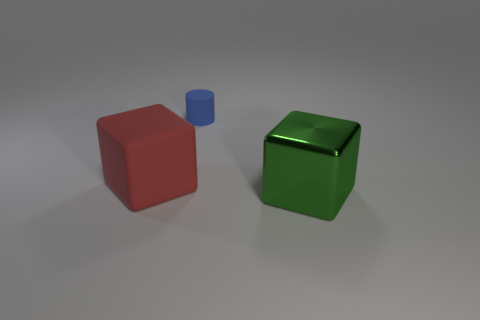Add 3 red rubber cubes. How many objects exist? 6 Subtract all cylinders. How many objects are left? 2 Add 3 brown rubber objects. How many brown rubber objects exist? 3 Subtract 0 cyan balls. How many objects are left? 3 Subtract all big purple cylinders. Subtract all tiny blue things. How many objects are left? 2 Add 2 red blocks. How many red blocks are left? 3 